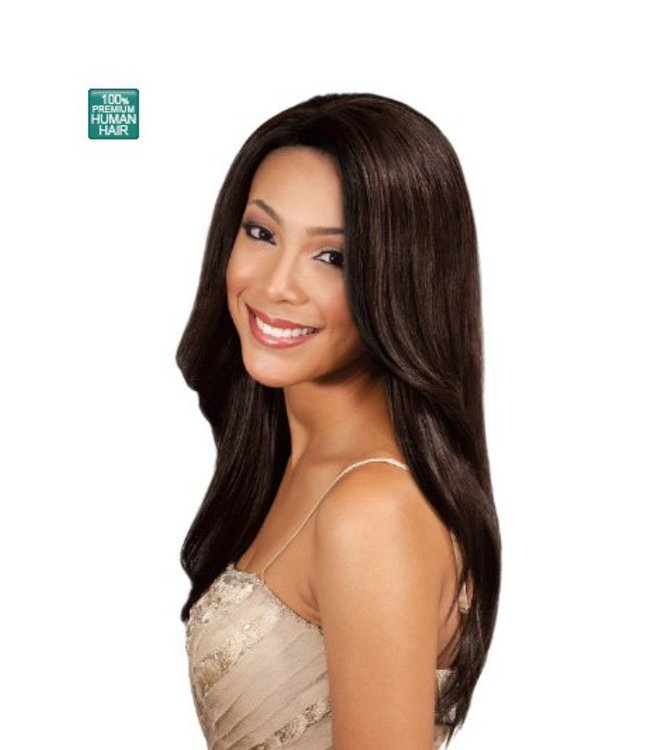If the wig could speak, what would it say about its experiences and journeys from production to being worn? If the wig could speak, it might say, "I began my journey in a place where hair was lovingly collected from willing donors, usually in a process that supports their communities. I traveled through skilled hands that cleaned, processed, and crafted me into my current form with great care and expertise. From there, I found myself ready to bring joy and confidence to someone seeking a transformation. Every time I am worn, I become a part of special moments – be it a job interview, a wedding, or a casual day out, I am here to enhance and celebrate the beauty of my wearer. And with every wear, I give a nod of gratitude to the journey that's brought me here, ready for new adventures and stories." Can you imagine a day in the life of this wig from the perspective of the wearer? Certainly! A day in the life of this wig from the perspective of the wearer might look like this:

*Morning:* The wearer starts the day by gently brushing the wig to ensure it's free of tangles and looks smooth and natural. As they place the wig on their head, they instantly feel a boost of confidence, ready to face the day.

*Work Day:* At work, the wig draws compliments from colleagues, admiring its realistic and polished look. The wearer feels professional and proud, knowing that the wig enhances their appearance.

*Lunch Break:* During lunch with a friend, there's laughter and conversation. The wearer feels relaxed, not worrying about their hair – the wig stays perfectly in place and looks great.

*Afternoon:* The wearer attends a crucial meeting. Their appearance enhances their demeanor, and they carry themselves with assurance, making a strong impression on their colleagues and clients.

*Evening:* After a productive day, the wearer heads home. They carefully remove the wig, giving their scalp a rest, and place it on a wig stand to maintain its shape.

*Night:* As the day ends, the wearer reflects on their accomplishments, feeling grateful for the small elements, like their wig, that contributed to their confidence and success. They go to sleep, ready to embrace another day with the sharegpt4v/same enthusiasm and poise. Imagine if the wig had a magical power to change hairstyles instantly. What adventures might it embark on with its wearer? Imagine the wig has a magical power to instantly change hairstyles! The wearer and the wig would embark on adventures that are only limited by their imagination:

*Morning:* They start with sleek, straight hair for a sophisticated look at a breakfast meeting with potential investors. The wig looks natural, giving the wearer a confident start to the day.

*Afternoon Adventure:* With a quick change to voluminous curls, they attend a photo shoot for a fashion magazine. The wig seamlessly transitions, adding flair and elegance to each outfit, making every frame captivating.

*Evening Gala:* As sunset approaches, the wig transforms into a classic updo just in time for a red-carpet event. The wearer feels glamorous walking past the flashing cameras and dazzling lights, with each step resonating with confidence.

*Late Night Fun:* Post-gala, the wig morphs into a chic bob for a night out with friends. The hairstyle draws admiration from onlookers at the hip, downtown bar where they're dancing the night away.

*Weekend Getaway:* On the weekend, the wig's magical powers transport them to a beach getaway. With gentle waves cascading down, the hairstyle perfectly complements the ocean breeze and relaxed vibes.

This magical wig and its wearer discover new experiences, transforming looks to meet every moment, making their journey filled with unforgettable memories and endless possibilities. 